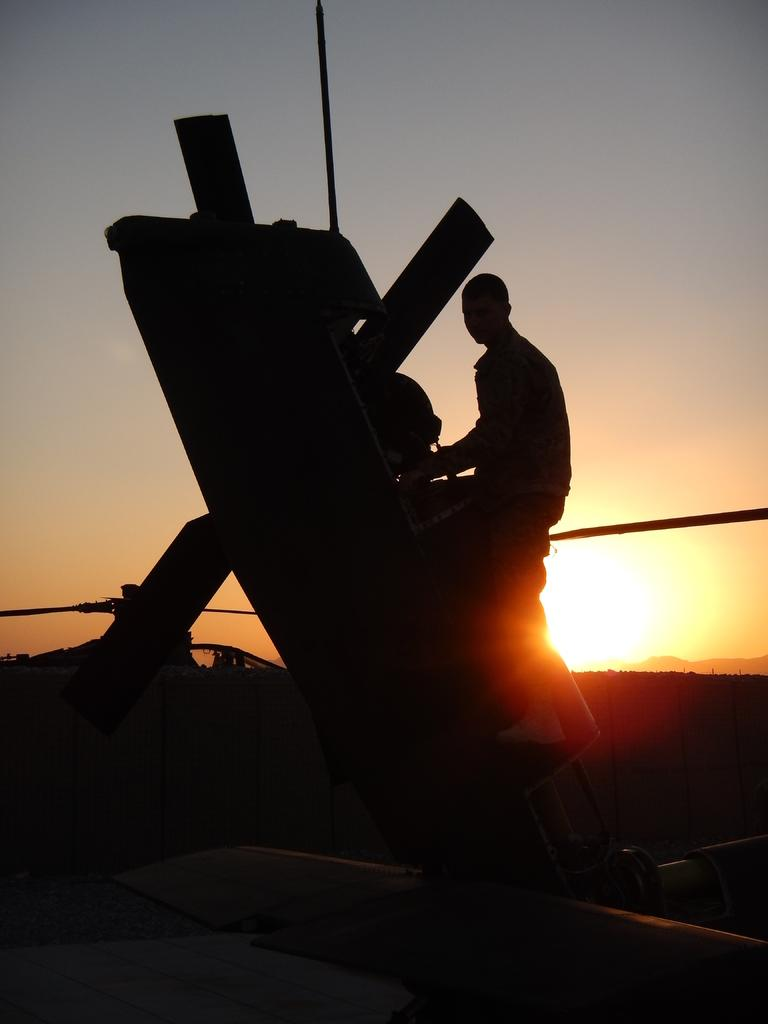What is the main subject in the image? There is an object in the image. Who is interacting with the object? A person is holding the object. How would you describe the sky in the image? The sky has grey, white, and orange colors. What type of lunch is being served in the image? There is no lunch present in the image; it only features an object being held by a person and a description of the sky's colors. 